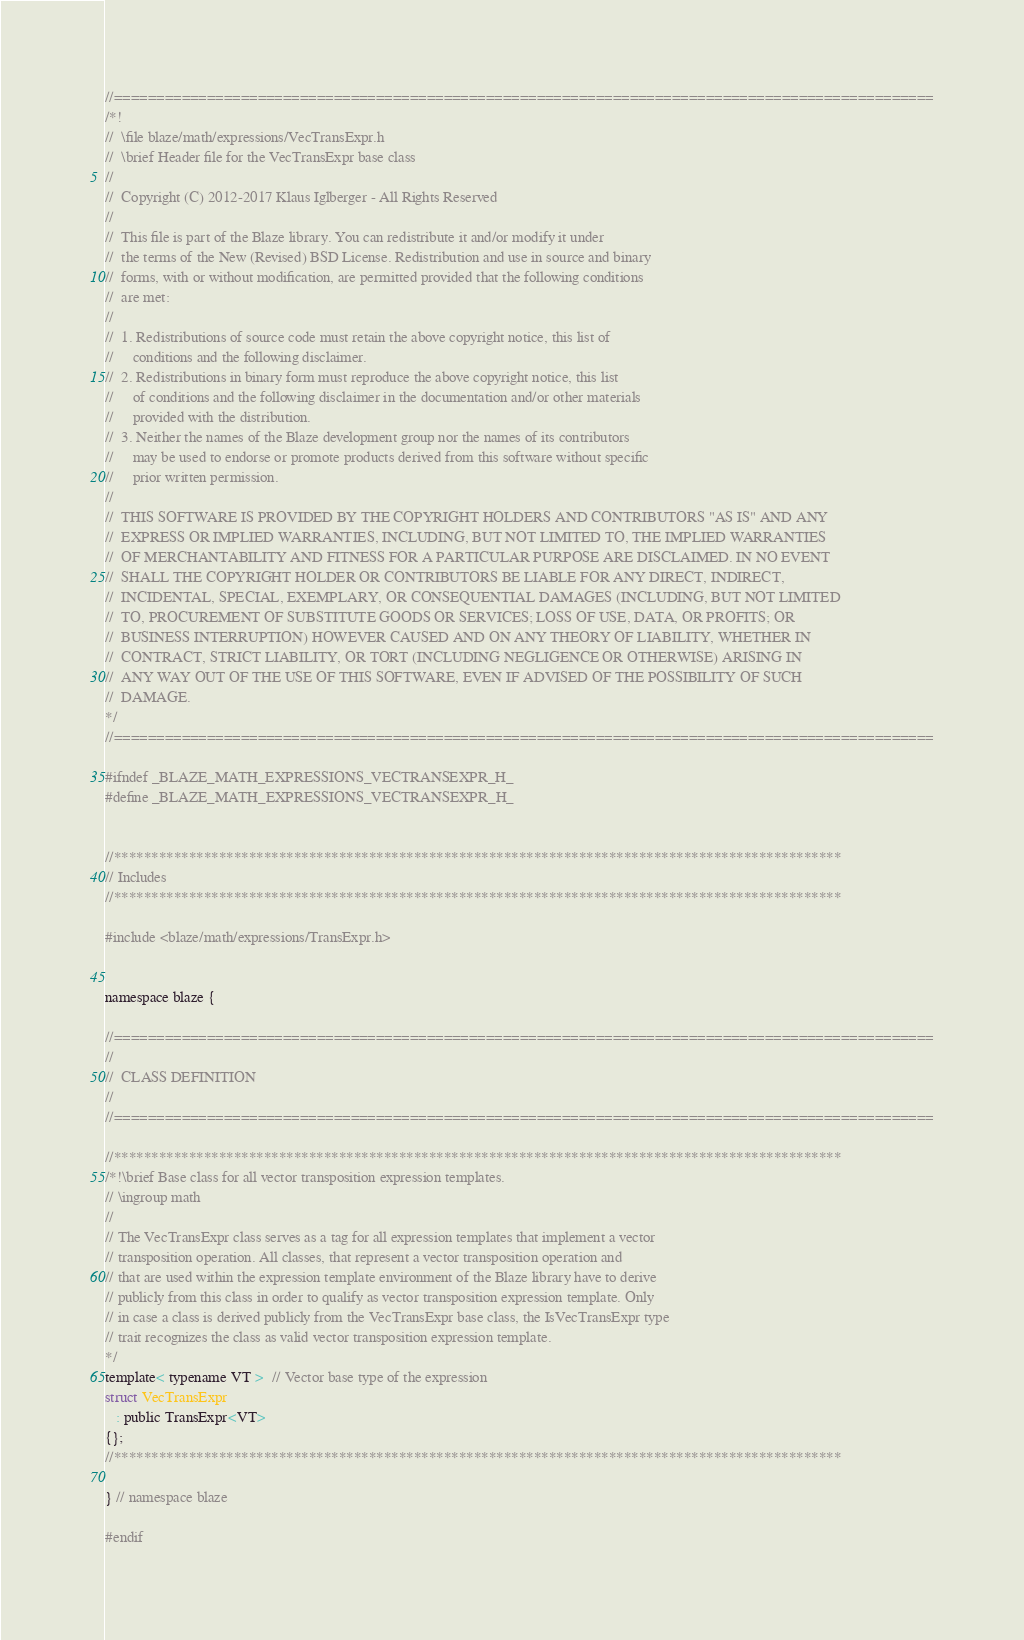<code> <loc_0><loc_0><loc_500><loc_500><_C_>//=================================================================================================
/*!
//  \file blaze/math/expressions/VecTransExpr.h
//  \brief Header file for the VecTransExpr base class
//
//  Copyright (C) 2012-2017 Klaus Iglberger - All Rights Reserved
//
//  This file is part of the Blaze library. You can redistribute it and/or modify it under
//  the terms of the New (Revised) BSD License. Redistribution and use in source and binary
//  forms, with or without modification, are permitted provided that the following conditions
//  are met:
//
//  1. Redistributions of source code must retain the above copyright notice, this list of
//     conditions and the following disclaimer.
//  2. Redistributions in binary form must reproduce the above copyright notice, this list
//     of conditions and the following disclaimer in the documentation and/or other materials
//     provided with the distribution.
//  3. Neither the names of the Blaze development group nor the names of its contributors
//     may be used to endorse or promote products derived from this software without specific
//     prior written permission.
//
//  THIS SOFTWARE IS PROVIDED BY THE COPYRIGHT HOLDERS AND CONTRIBUTORS "AS IS" AND ANY
//  EXPRESS OR IMPLIED WARRANTIES, INCLUDING, BUT NOT LIMITED TO, THE IMPLIED WARRANTIES
//  OF MERCHANTABILITY AND FITNESS FOR A PARTICULAR PURPOSE ARE DISCLAIMED. IN NO EVENT
//  SHALL THE COPYRIGHT HOLDER OR CONTRIBUTORS BE LIABLE FOR ANY DIRECT, INDIRECT,
//  INCIDENTAL, SPECIAL, EXEMPLARY, OR CONSEQUENTIAL DAMAGES (INCLUDING, BUT NOT LIMITED
//  TO, PROCUREMENT OF SUBSTITUTE GOODS OR SERVICES; LOSS OF USE, DATA, OR PROFITS; OR
//  BUSINESS INTERRUPTION) HOWEVER CAUSED AND ON ANY THEORY OF LIABILITY, WHETHER IN
//  CONTRACT, STRICT LIABILITY, OR TORT (INCLUDING NEGLIGENCE OR OTHERWISE) ARISING IN
//  ANY WAY OUT OF THE USE OF THIS SOFTWARE, EVEN IF ADVISED OF THE POSSIBILITY OF SUCH
//  DAMAGE.
*/
//=================================================================================================

#ifndef _BLAZE_MATH_EXPRESSIONS_VECTRANSEXPR_H_
#define _BLAZE_MATH_EXPRESSIONS_VECTRANSEXPR_H_


//*************************************************************************************************
// Includes
//*************************************************************************************************

#include <blaze/math/expressions/TransExpr.h>


namespace blaze {

//=================================================================================================
//
//  CLASS DEFINITION
//
//=================================================================================================

//*************************************************************************************************
/*!\brief Base class for all vector transposition expression templates.
// \ingroup math
//
// The VecTransExpr class serves as a tag for all expression templates that implement a vector
// transposition operation. All classes, that represent a vector transposition operation and
// that are used within the expression template environment of the Blaze library have to derive
// publicly from this class in order to qualify as vector transposition expression template. Only
// in case a class is derived publicly from the VecTransExpr base class, the IsVecTransExpr type
// trait recognizes the class as valid vector transposition expression template.
*/
template< typename VT >  // Vector base type of the expression
struct VecTransExpr
   : public TransExpr<VT>
{};
//*************************************************************************************************

} // namespace blaze

#endif
</code> 